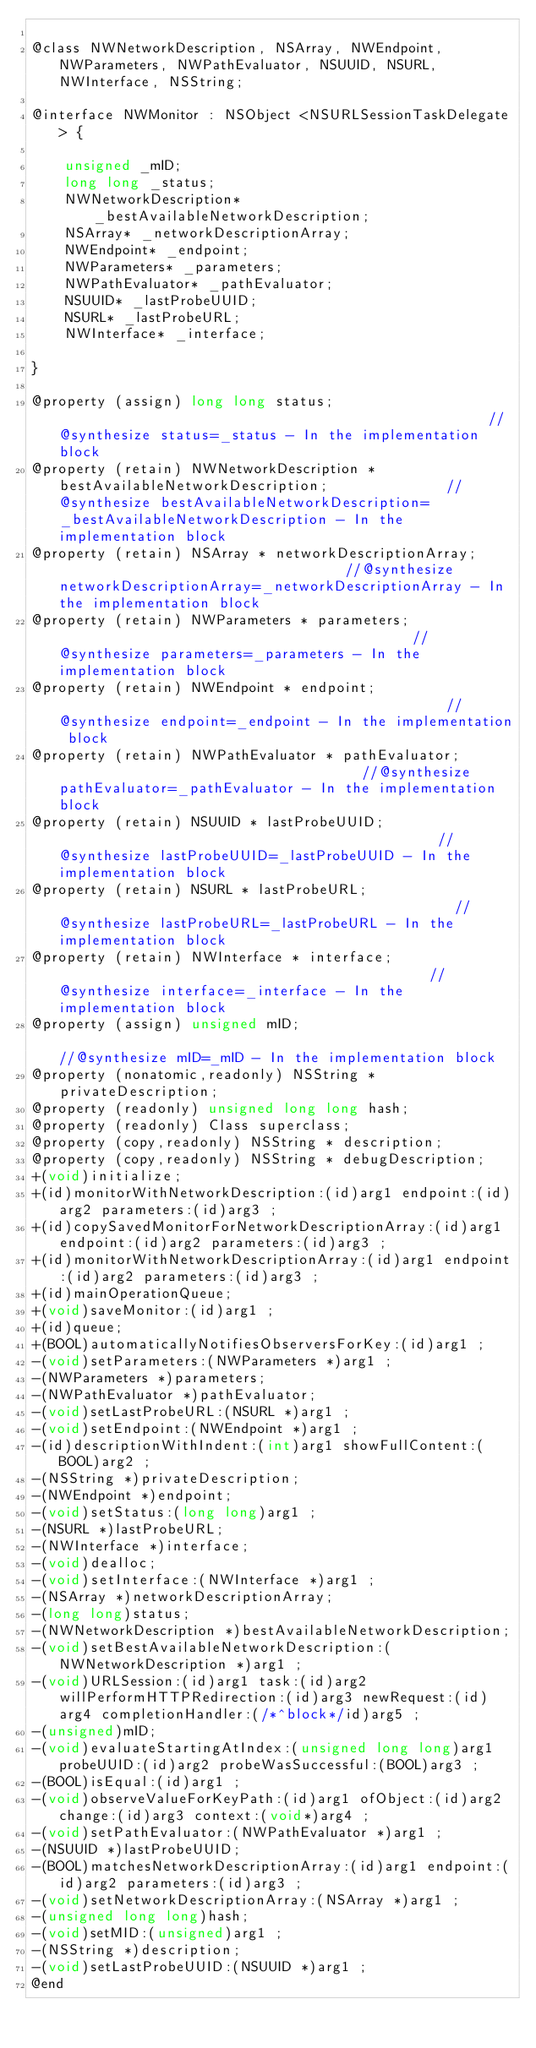<code> <loc_0><loc_0><loc_500><loc_500><_C_>
@class NWNetworkDescription, NSArray, NWEndpoint, NWParameters, NWPathEvaluator, NSUUID, NSURL, NWInterface, NSString;

@interface NWMonitor : NSObject <NSURLSessionTaskDelegate> {

	unsigned _mID;
	long long _status;
	NWNetworkDescription* _bestAvailableNetworkDescription;
	NSArray* _networkDescriptionArray;
	NWEndpoint* _endpoint;
	NWParameters* _parameters;
	NWPathEvaluator* _pathEvaluator;
	NSUUID* _lastProbeUUID;
	NSURL* _lastProbeURL;
	NWInterface* _interface;

}

@property (assign) long long status;                                                    //@synthesize status=_status - In the implementation block
@property (retain) NWNetworkDescription * bestAvailableNetworkDescription;              //@synthesize bestAvailableNetworkDescription=_bestAvailableNetworkDescription - In the implementation block
@property (retain) NSArray * networkDescriptionArray;                                   //@synthesize networkDescriptionArray=_networkDescriptionArray - In the implementation block
@property (retain) NWParameters * parameters;                                           //@synthesize parameters=_parameters - In the implementation block
@property (retain) NWEndpoint * endpoint;                                               //@synthesize endpoint=_endpoint - In the implementation block
@property (retain) NWPathEvaluator * pathEvaluator;                                     //@synthesize pathEvaluator=_pathEvaluator - In the implementation block
@property (retain) NSUUID * lastProbeUUID;                                              //@synthesize lastProbeUUID=_lastProbeUUID - In the implementation block
@property (retain) NSURL * lastProbeURL;                                                //@synthesize lastProbeURL=_lastProbeURL - In the implementation block
@property (retain) NWInterface * interface;                                             //@synthesize interface=_interface - In the implementation block
@property (assign) unsigned mID;                                                        //@synthesize mID=_mID - In the implementation block
@property (nonatomic,readonly) NSString * privateDescription; 
@property (readonly) unsigned long long hash; 
@property (readonly) Class superclass; 
@property (copy,readonly) NSString * description; 
@property (copy,readonly) NSString * debugDescription; 
+(void)initialize;
+(id)monitorWithNetworkDescription:(id)arg1 endpoint:(id)arg2 parameters:(id)arg3 ;
+(id)copySavedMonitorForNetworkDescriptionArray:(id)arg1 endpoint:(id)arg2 parameters:(id)arg3 ;
+(id)monitorWithNetworkDescriptionArray:(id)arg1 endpoint:(id)arg2 parameters:(id)arg3 ;
+(id)mainOperationQueue;
+(void)saveMonitor:(id)arg1 ;
+(id)queue;
+(BOOL)automaticallyNotifiesObserversForKey:(id)arg1 ;
-(void)setParameters:(NWParameters *)arg1 ;
-(NWParameters *)parameters;
-(NWPathEvaluator *)pathEvaluator;
-(void)setLastProbeURL:(NSURL *)arg1 ;
-(void)setEndpoint:(NWEndpoint *)arg1 ;
-(id)descriptionWithIndent:(int)arg1 showFullContent:(BOOL)arg2 ;
-(NSString *)privateDescription;
-(NWEndpoint *)endpoint;
-(void)setStatus:(long long)arg1 ;
-(NSURL *)lastProbeURL;
-(NWInterface *)interface;
-(void)dealloc;
-(void)setInterface:(NWInterface *)arg1 ;
-(NSArray *)networkDescriptionArray;
-(long long)status;
-(NWNetworkDescription *)bestAvailableNetworkDescription;
-(void)setBestAvailableNetworkDescription:(NWNetworkDescription *)arg1 ;
-(void)URLSession:(id)arg1 task:(id)arg2 willPerformHTTPRedirection:(id)arg3 newRequest:(id)arg4 completionHandler:(/*^block*/id)arg5 ;
-(unsigned)mID;
-(void)evaluateStartingAtIndex:(unsigned long long)arg1 probeUUID:(id)arg2 probeWasSuccessful:(BOOL)arg3 ;
-(BOOL)isEqual:(id)arg1 ;
-(void)observeValueForKeyPath:(id)arg1 ofObject:(id)arg2 change:(id)arg3 context:(void*)arg4 ;
-(void)setPathEvaluator:(NWPathEvaluator *)arg1 ;
-(NSUUID *)lastProbeUUID;
-(BOOL)matchesNetworkDescriptionArray:(id)arg1 endpoint:(id)arg2 parameters:(id)arg3 ;
-(void)setNetworkDescriptionArray:(NSArray *)arg1 ;
-(unsigned long long)hash;
-(void)setMID:(unsigned)arg1 ;
-(NSString *)description;
-(void)setLastProbeUUID:(NSUUID *)arg1 ;
@end

</code> 